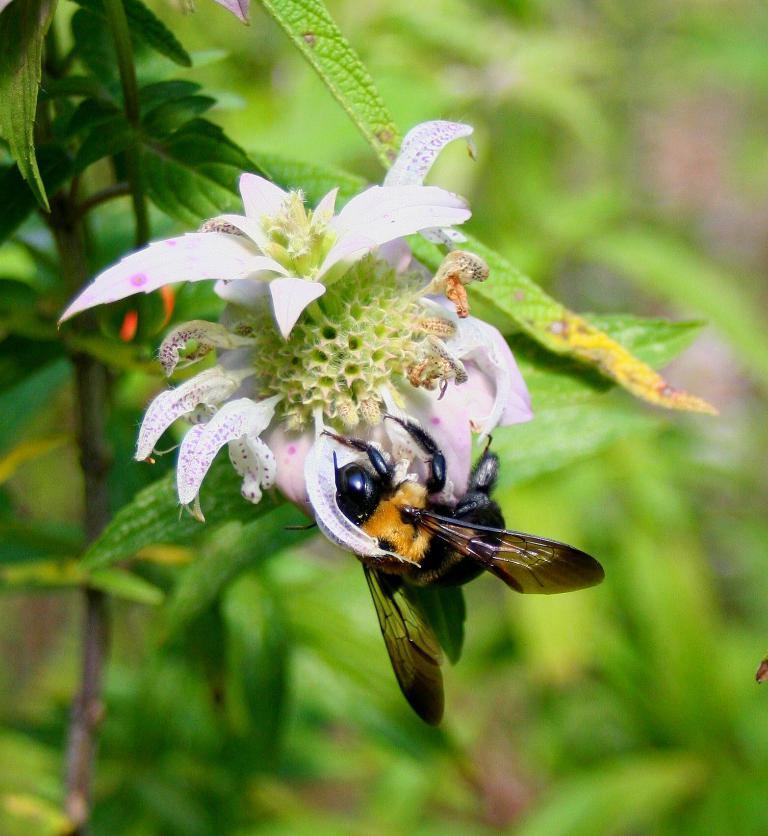How would you summarize this image in a sentence or two? Here in this picture we can see a bee present on a flower, which is present on a plant over there. 